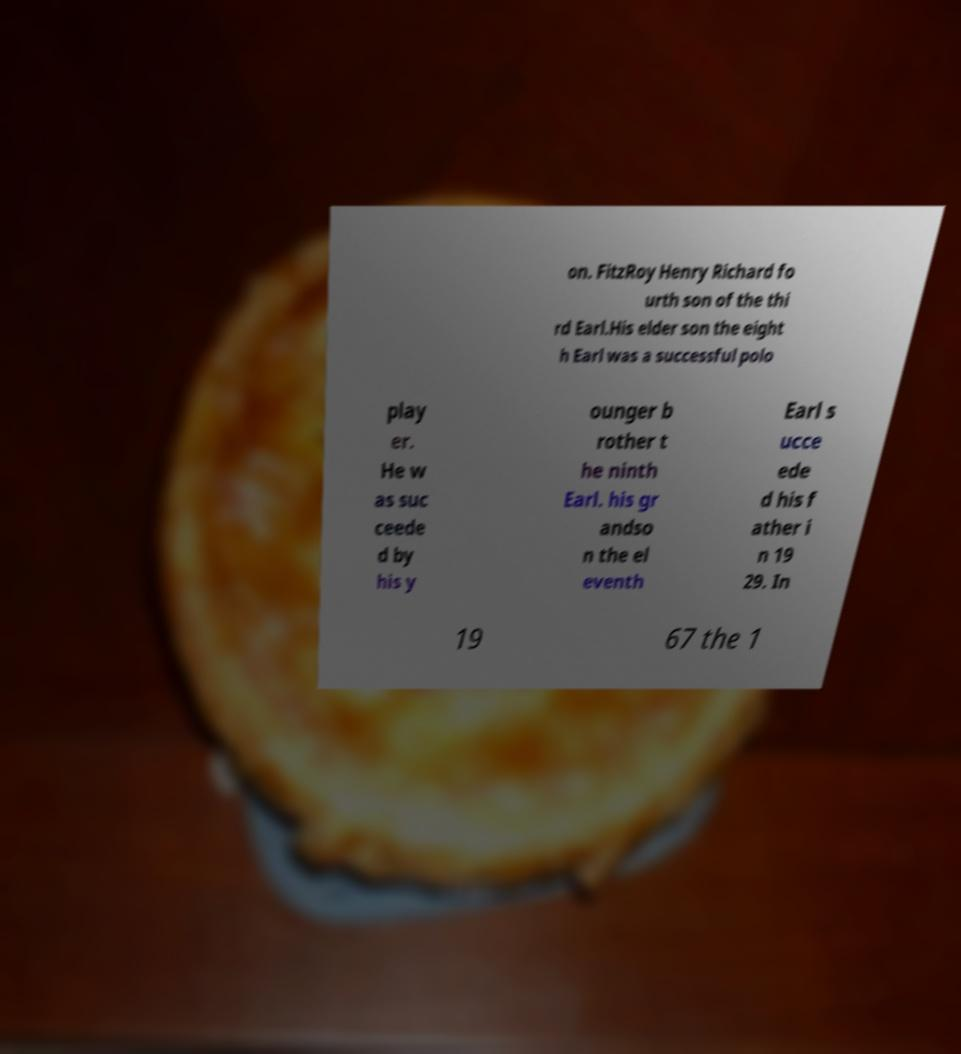Could you extract and type out the text from this image? on. FitzRoy Henry Richard fo urth son of the thi rd Earl.His elder son the eight h Earl was a successful polo play er. He w as suc ceede d by his y ounger b rother t he ninth Earl. his gr andso n the el eventh Earl s ucce ede d his f ather i n 19 29. In 19 67 the 1 